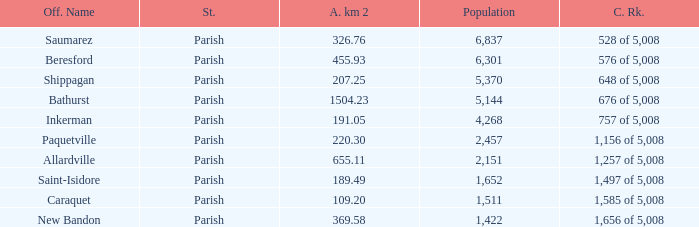What is the Population of the New Bandon Parish with an Area km 2 larger than 326.76? 1422.0. Would you mind parsing the complete table? {'header': ['Off. Name', 'St.', 'A. km 2', 'Population', 'C. Rk.'], 'rows': [['Saumarez', 'Parish', '326.76', '6,837', '528 of 5,008'], ['Beresford', 'Parish', '455.93', '6,301', '576 of 5,008'], ['Shippagan', 'Parish', '207.25', '5,370', '648 of 5,008'], ['Bathurst', 'Parish', '1504.23', '5,144', '676 of 5,008'], ['Inkerman', 'Parish', '191.05', '4,268', '757 of 5,008'], ['Paquetville', 'Parish', '220.30', '2,457', '1,156 of 5,008'], ['Allardville', 'Parish', '655.11', '2,151', '1,257 of 5,008'], ['Saint-Isidore', 'Parish', '189.49', '1,652', '1,497 of 5,008'], ['Caraquet', 'Parish', '109.20', '1,511', '1,585 of 5,008'], ['New Bandon', 'Parish', '369.58', '1,422', '1,656 of 5,008']]} 